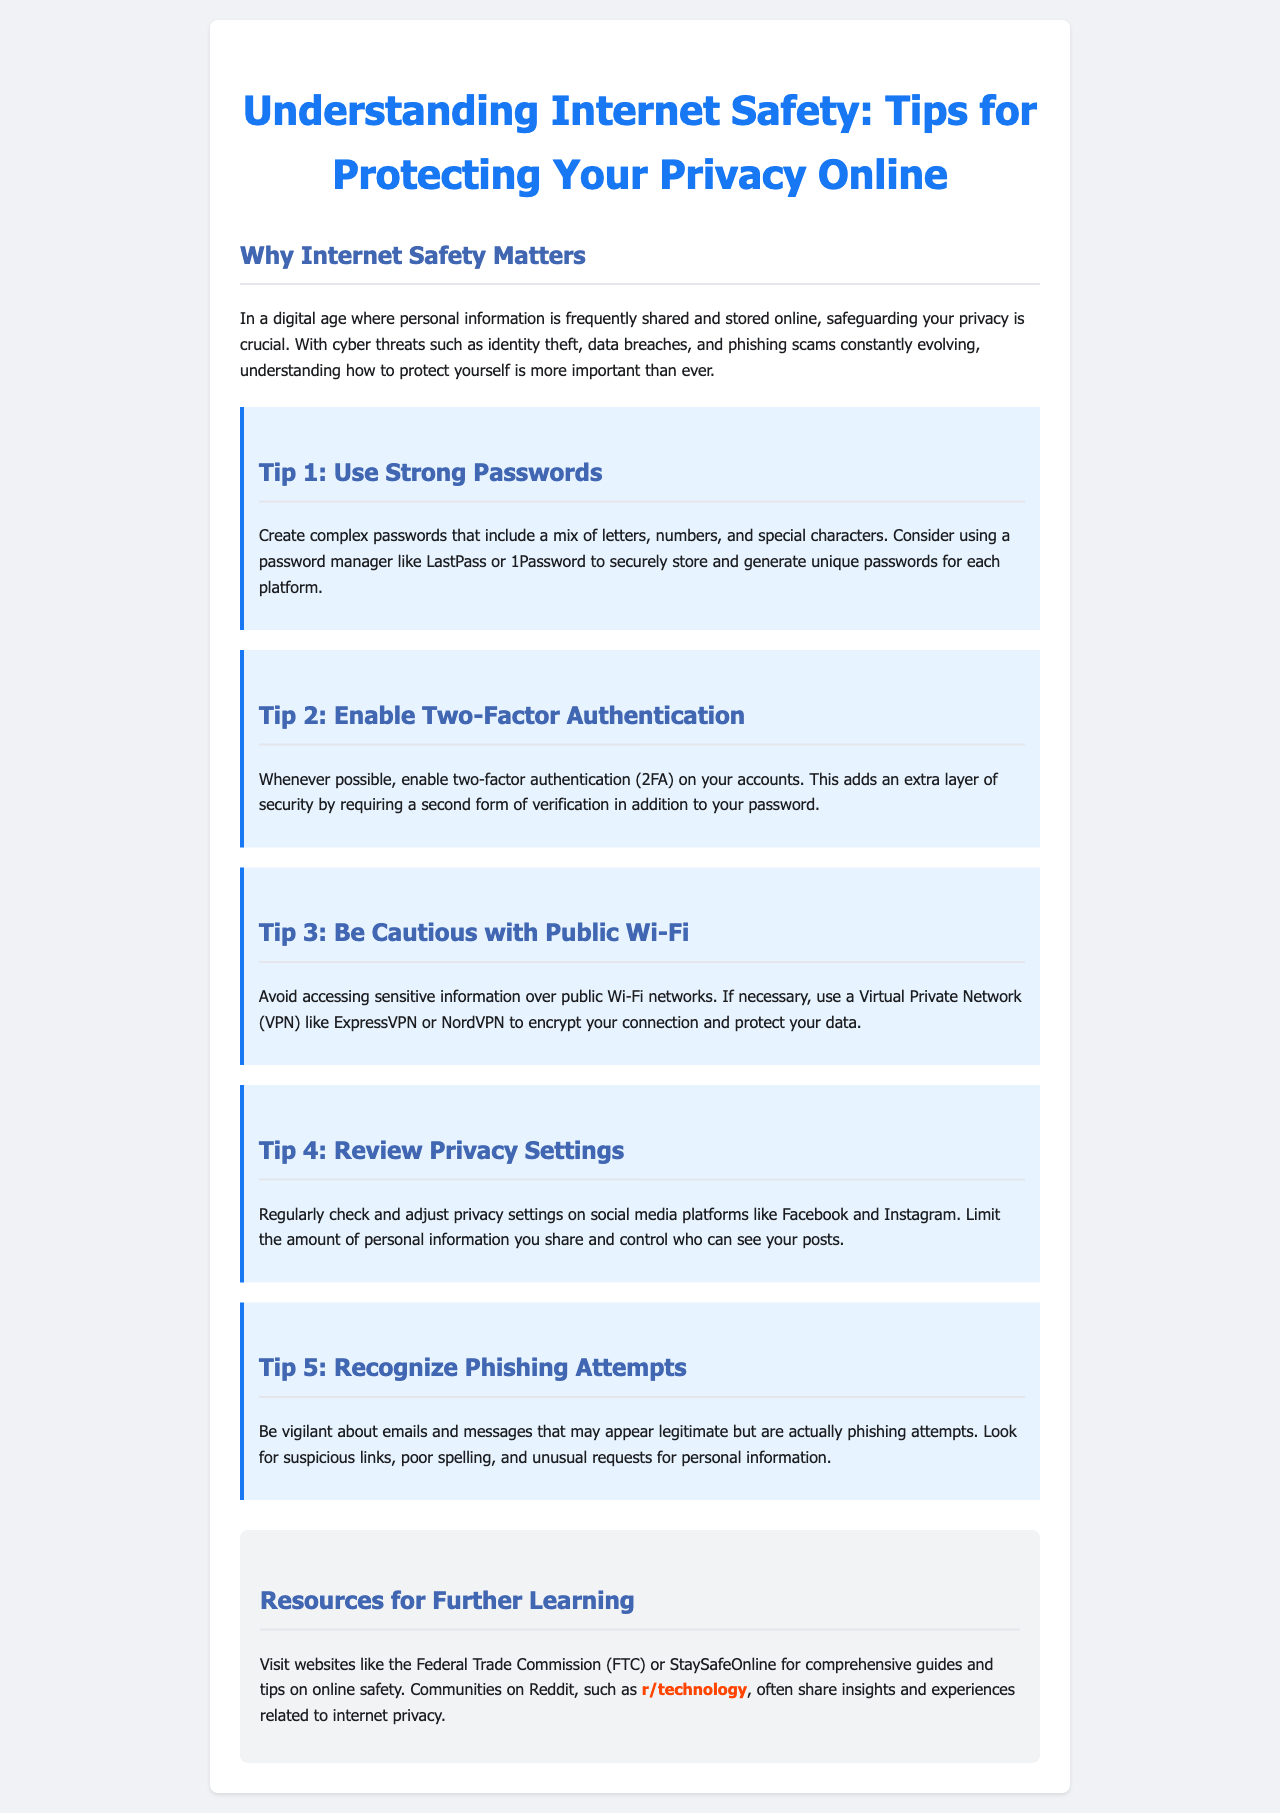What is the title of the brochure? The title of the brochure is usually found at the top and summarizes its content, which is "Understanding Internet Safety: Tips for Protecting Your Privacy Online."
Answer: Understanding Internet Safety: Tips for Protecting Your Privacy Online How many tips are provided in the document? The document lists five specific tips for protecting privacy online, making it a concisely organized piece.
Answer: 5 What should be included in strong passwords? The document specifies that strong passwords should include a mix of letters, numbers, and special characters for better security.
Answer: A mix of letters, numbers, and special characters What is the purpose of two-factor authentication? The document states that two-factor authentication adds an extra layer of security by requiring a second form of verification.
Answer: An extra layer of security What is one recommended tool to use over public Wi-Fi? The document suggests using a Virtual Private Network (VPN) like ExpressVPN or NordVPN to protect data on public networks.
Answer: VPN Which social media platforms should users review privacy settings on? The document mentions Facebook and Instagram specifically for checking and adjusting privacy settings.
Answer: Facebook and Instagram What type of email should you be cautious of? The document warns about emails and messages that may appear legitimate but are actually phishing attempts, highlighting a specific type of online threat.
Answer: Phishing attempts What resources are suggested for further learning? The document recommends websites like the Federal Trade Commission (FTC) and StaySafeOnline for comprehensive guides on online safety.
Answer: FTC and StaySafeOnline 